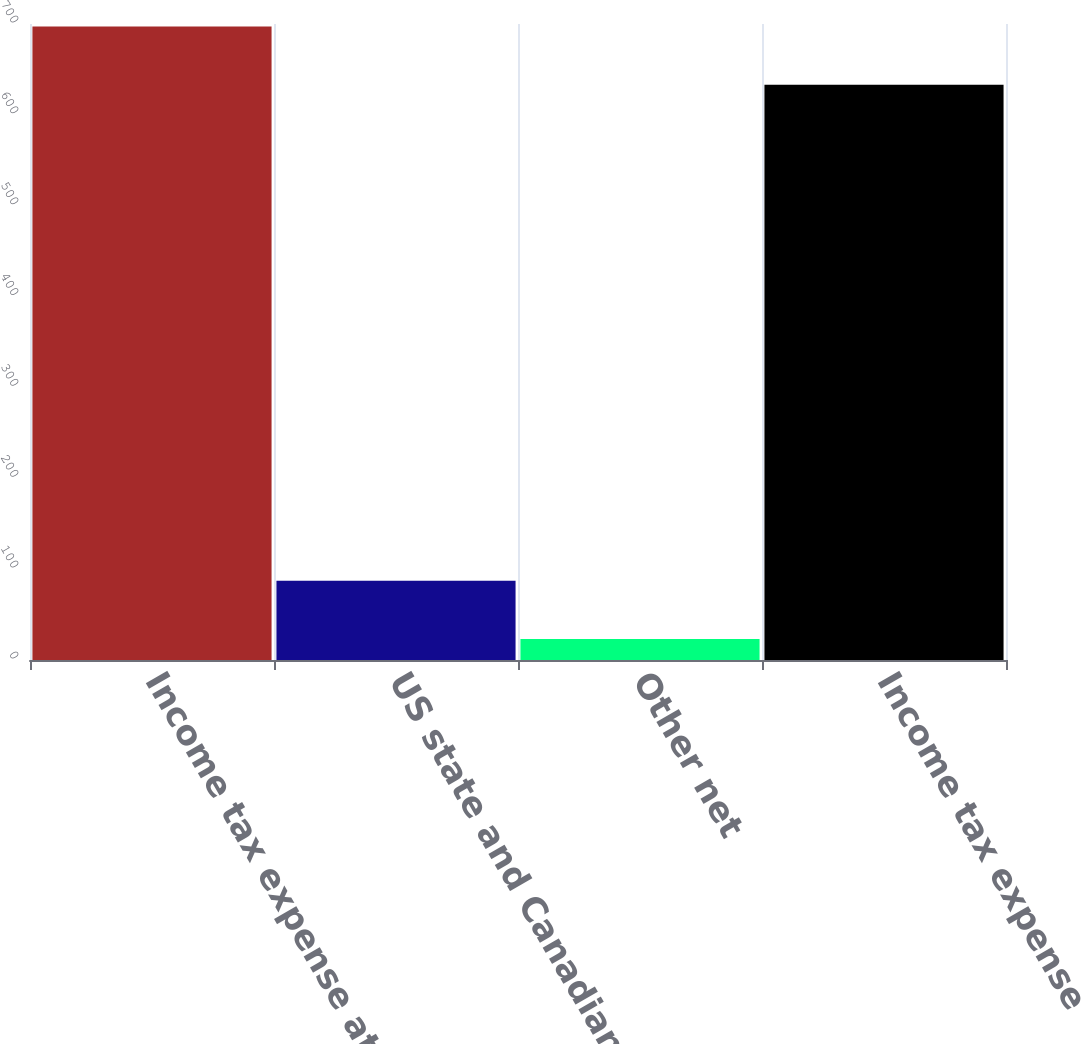<chart> <loc_0><loc_0><loc_500><loc_500><bar_chart><fcel>Income tax expense at<fcel>US state and Canadian<fcel>Other net<fcel>Income tax expense<nl><fcel>697.2<fcel>87.2<fcel>23<fcel>633<nl></chart> 